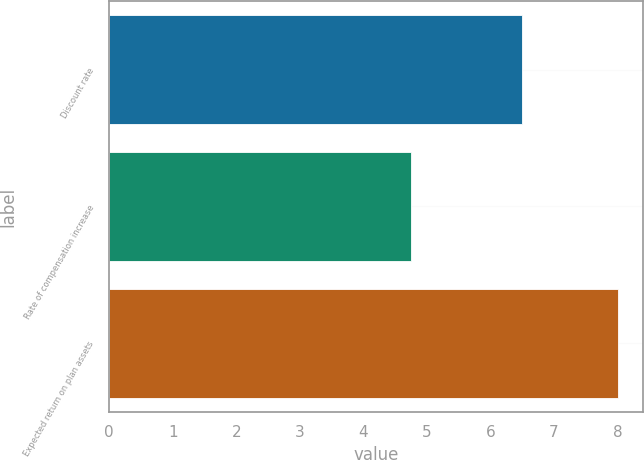Convert chart. <chart><loc_0><loc_0><loc_500><loc_500><bar_chart><fcel>Discount rate<fcel>Rate of compensation increase<fcel>Expected return on plan assets<nl><fcel>6.5<fcel>4.75<fcel>8<nl></chart> 